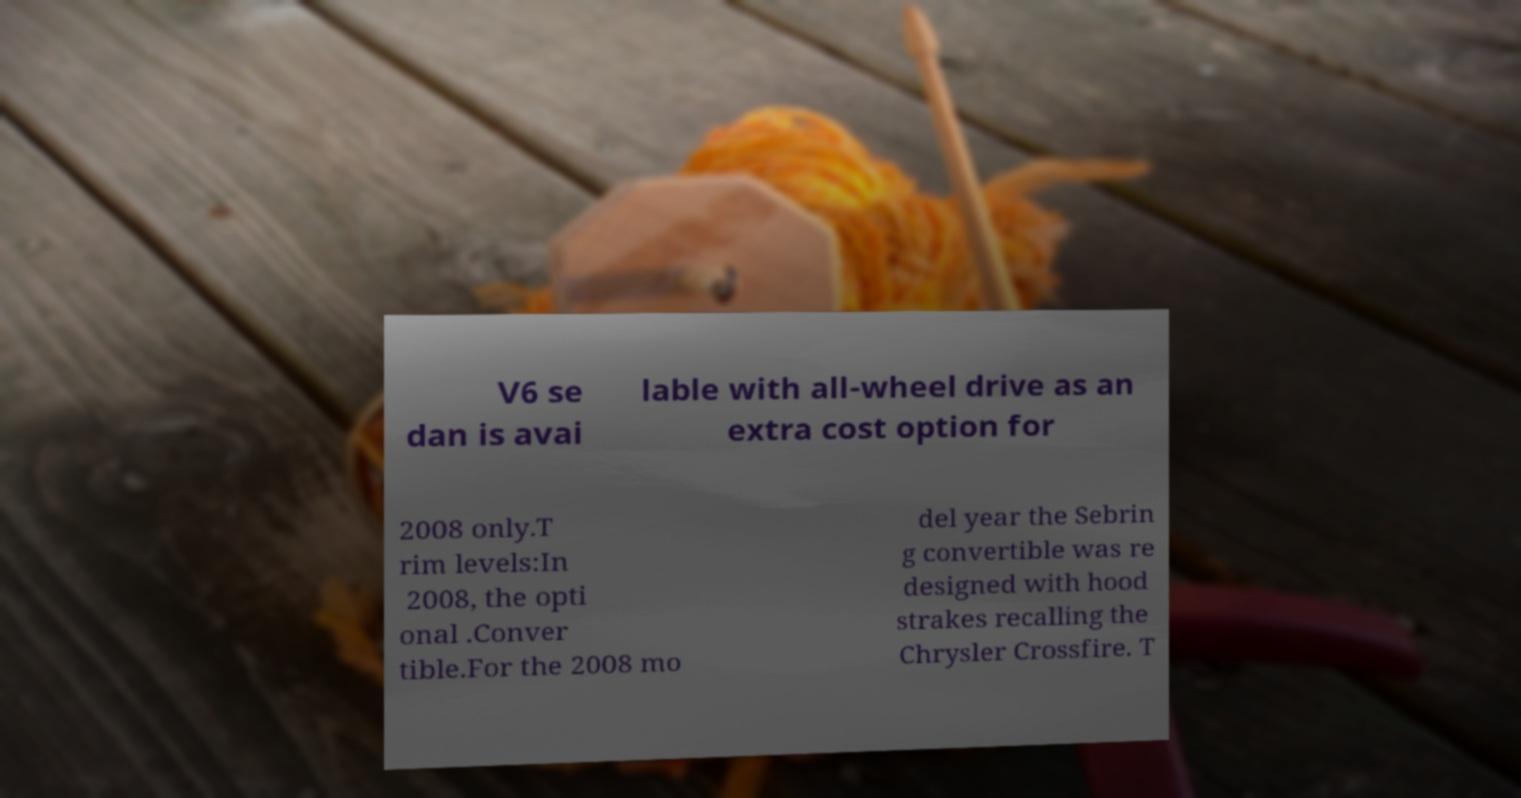Could you extract and type out the text from this image? V6 se dan is avai lable with all-wheel drive as an extra cost option for 2008 only.T rim levels:In 2008, the opti onal .Conver tible.For the 2008 mo del year the Sebrin g convertible was re designed with hood strakes recalling the Chrysler Crossfire. T 